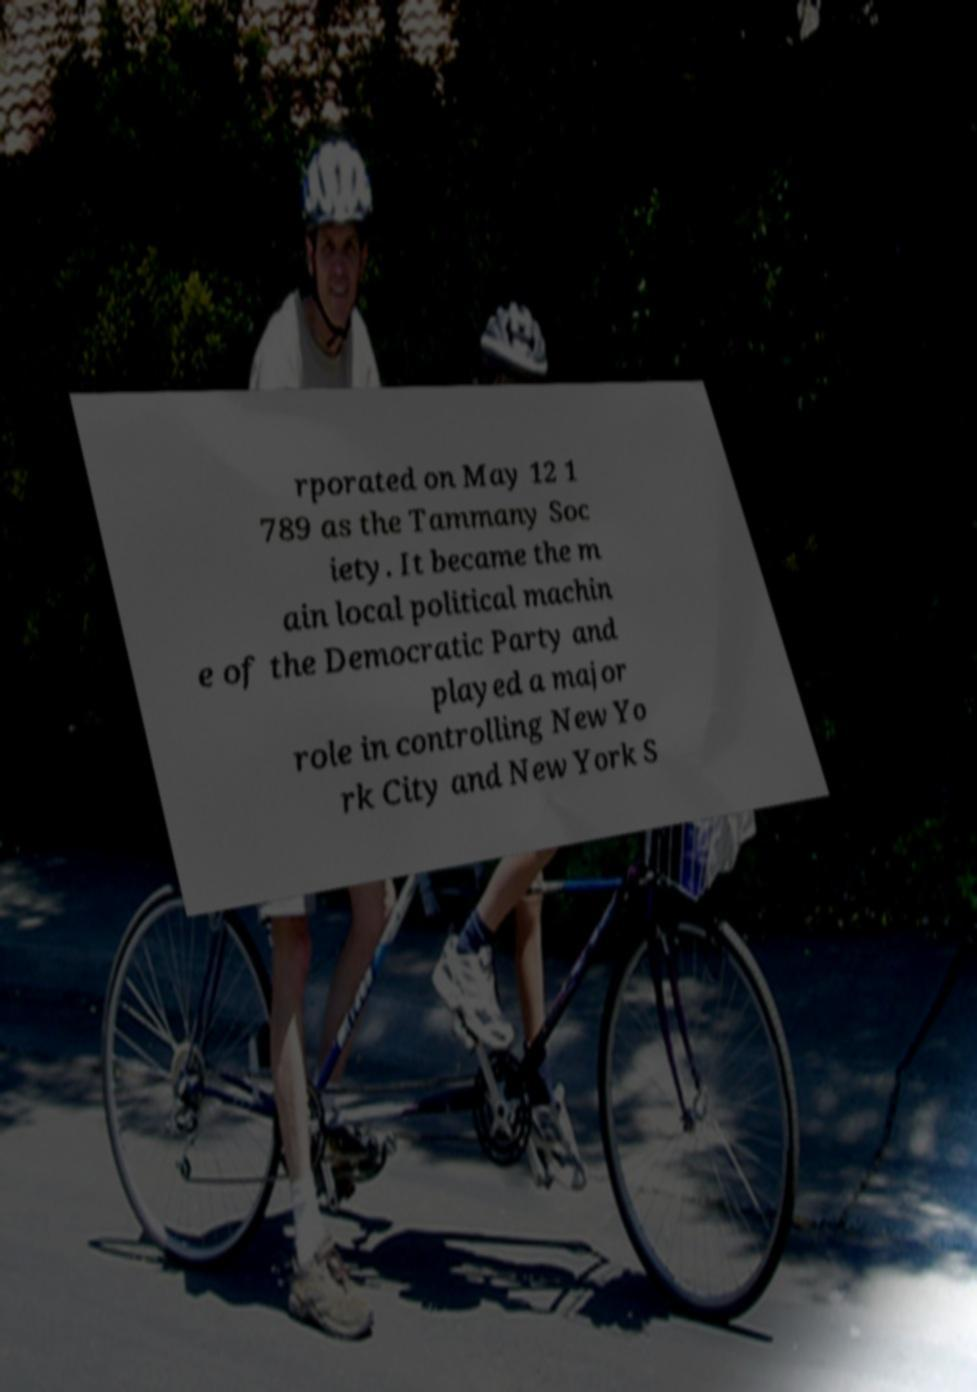Could you assist in decoding the text presented in this image and type it out clearly? rporated on May 12 1 789 as the Tammany Soc iety. It became the m ain local political machin e of the Democratic Party and played a major role in controlling New Yo rk City and New York S 